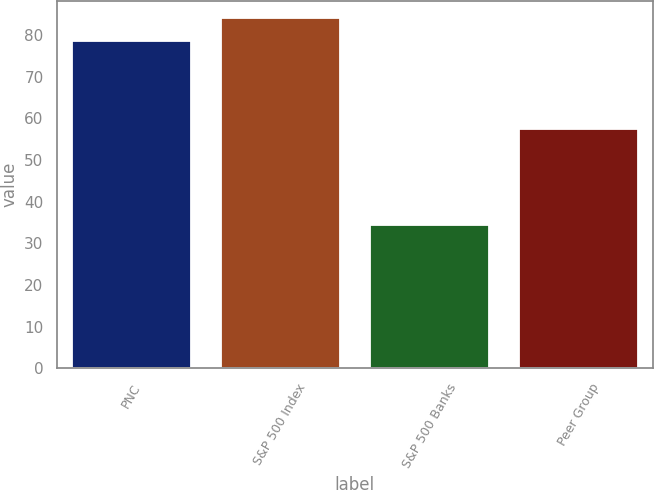Convert chart. <chart><loc_0><loc_0><loc_500><loc_500><bar_chart><fcel>PNC<fcel>S&P 500 Index<fcel>S&P 500 Banks<fcel>Peer Group<nl><fcel>78.7<fcel>84.05<fcel>34.44<fcel>57.56<nl></chart> 